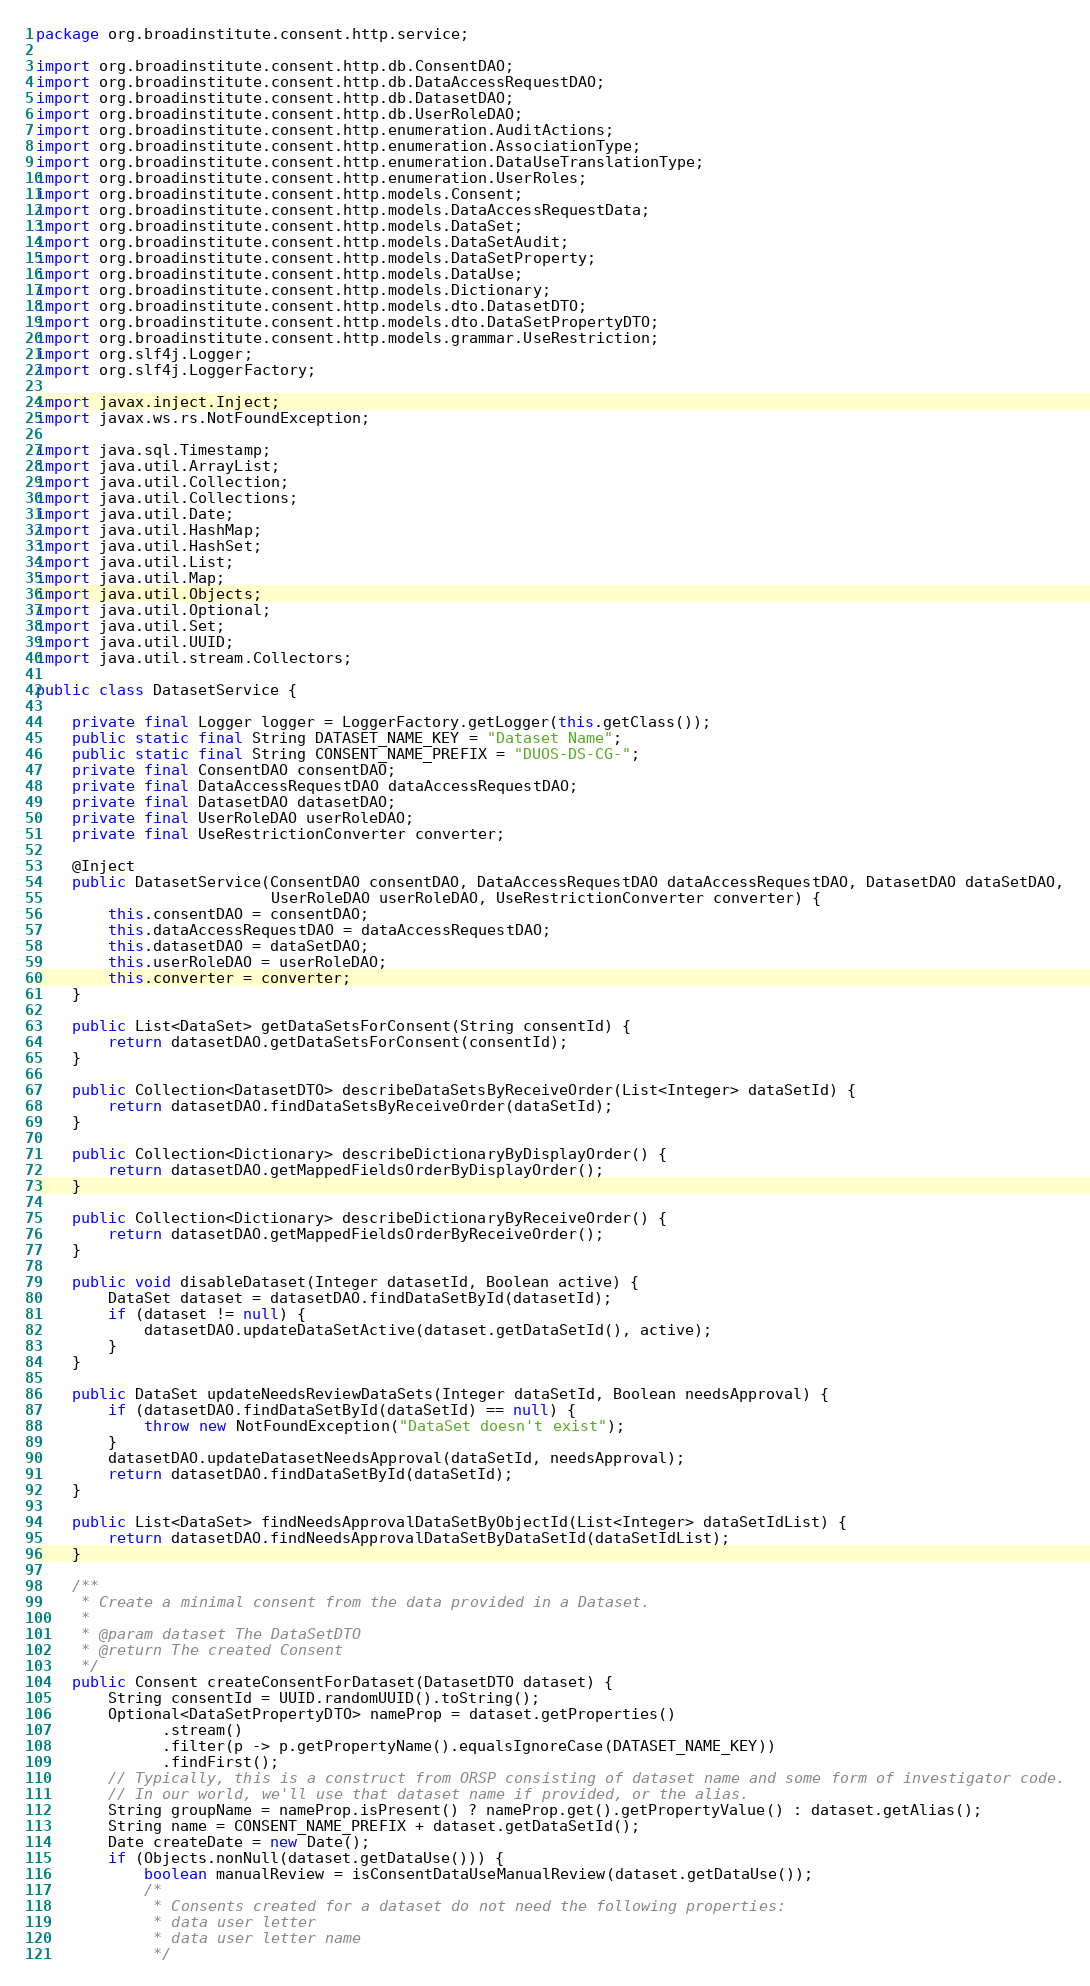Convert code to text. <code><loc_0><loc_0><loc_500><loc_500><_Java_>package org.broadinstitute.consent.http.service;

import org.broadinstitute.consent.http.db.ConsentDAO;
import org.broadinstitute.consent.http.db.DataAccessRequestDAO;
import org.broadinstitute.consent.http.db.DatasetDAO;
import org.broadinstitute.consent.http.db.UserRoleDAO;
import org.broadinstitute.consent.http.enumeration.AuditActions;
import org.broadinstitute.consent.http.enumeration.AssociationType;
import org.broadinstitute.consent.http.enumeration.DataUseTranslationType;
import org.broadinstitute.consent.http.enumeration.UserRoles;
import org.broadinstitute.consent.http.models.Consent;
import org.broadinstitute.consent.http.models.DataAccessRequestData;
import org.broadinstitute.consent.http.models.DataSet;
import org.broadinstitute.consent.http.models.DataSetAudit;
import org.broadinstitute.consent.http.models.DataSetProperty;
import org.broadinstitute.consent.http.models.DataUse;
import org.broadinstitute.consent.http.models.Dictionary;
import org.broadinstitute.consent.http.models.dto.DatasetDTO;
import org.broadinstitute.consent.http.models.dto.DataSetPropertyDTO;
import org.broadinstitute.consent.http.models.grammar.UseRestriction;
import org.slf4j.Logger;
import org.slf4j.LoggerFactory;

import javax.inject.Inject;
import javax.ws.rs.NotFoundException;

import java.sql.Timestamp;
import java.util.ArrayList;
import java.util.Collection;
import java.util.Collections;
import java.util.Date;
import java.util.HashMap;
import java.util.HashSet;
import java.util.List;
import java.util.Map;
import java.util.Objects;
import java.util.Optional;
import java.util.Set;
import java.util.UUID;
import java.util.stream.Collectors;

public class DatasetService {

    private final Logger logger = LoggerFactory.getLogger(this.getClass());
    public static final String DATASET_NAME_KEY = "Dataset Name";
    public static final String CONSENT_NAME_PREFIX = "DUOS-DS-CG-";
    private final ConsentDAO consentDAO;
    private final DataAccessRequestDAO dataAccessRequestDAO;
    private final DatasetDAO datasetDAO;
    private final UserRoleDAO userRoleDAO;
    private final UseRestrictionConverter converter;

    @Inject
    public DatasetService(ConsentDAO consentDAO, DataAccessRequestDAO dataAccessRequestDAO, DatasetDAO dataSetDAO,
                          UserRoleDAO userRoleDAO, UseRestrictionConverter converter) {
        this.consentDAO = consentDAO;
        this.dataAccessRequestDAO = dataAccessRequestDAO;
        this.datasetDAO = dataSetDAO;
        this.userRoleDAO = userRoleDAO;
        this.converter = converter;
    }

    public List<DataSet> getDataSetsForConsent(String consentId) {
        return datasetDAO.getDataSetsForConsent(consentId);
    }

    public Collection<DatasetDTO> describeDataSetsByReceiveOrder(List<Integer> dataSetId) {
        return datasetDAO.findDataSetsByReceiveOrder(dataSetId);
    }

    public Collection<Dictionary> describeDictionaryByDisplayOrder() {
        return datasetDAO.getMappedFieldsOrderByDisplayOrder();
    }

    public Collection<Dictionary> describeDictionaryByReceiveOrder() {
        return datasetDAO.getMappedFieldsOrderByReceiveOrder();
    }

    public void disableDataset(Integer datasetId, Boolean active) {
        DataSet dataset = datasetDAO.findDataSetById(datasetId);
        if (dataset != null) {
            datasetDAO.updateDataSetActive(dataset.getDataSetId(), active);
        }
    }

    public DataSet updateNeedsReviewDataSets(Integer dataSetId, Boolean needsApproval) {
        if (datasetDAO.findDataSetById(dataSetId) == null) {
            throw new NotFoundException("DataSet doesn't exist");
        }
        datasetDAO.updateDatasetNeedsApproval(dataSetId, needsApproval);
        return datasetDAO.findDataSetById(dataSetId);
    }

    public List<DataSet> findNeedsApprovalDataSetByObjectId(List<Integer> dataSetIdList) {
        return datasetDAO.findNeedsApprovalDataSetByDataSetId(dataSetIdList);
    }

    /**
     * Create a minimal consent from the data provided in a Dataset.
     *
     * @param dataset The DataSetDTO
     * @return The created Consent
     */
    public Consent createConsentForDataset(DatasetDTO dataset) {
        String consentId = UUID.randomUUID().toString();
        Optional<DataSetPropertyDTO> nameProp = dataset.getProperties()
              .stream()
              .filter(p -> p.getPropertyName().equalsIgnoreCase(DATASET_NAME_KEY))
              .findFirst();
        // Typically, this is a construct from ORSP consisting of dataset name and some form of investigator code.
        // In our world, we'll use that dataset name if provided, or the alias.
        String groupName = nameProp.isPresent() ? nameProp.get().getPropertyValue() : dataset.getAlias();
        String name = CONSENT_NAME_PREFIX + dataset.getDataSetId();
        Date createDate = new Date();
        if (Objects.nonNull(dataset.getDataUse())) {
            boolean manualReview = isConsentDataUseManualReview(dataset.getDataUse());
            /*
             * Consents created for a dataset do not need the following properties:
             * data user letter
             * data user letter name
             */</code> 